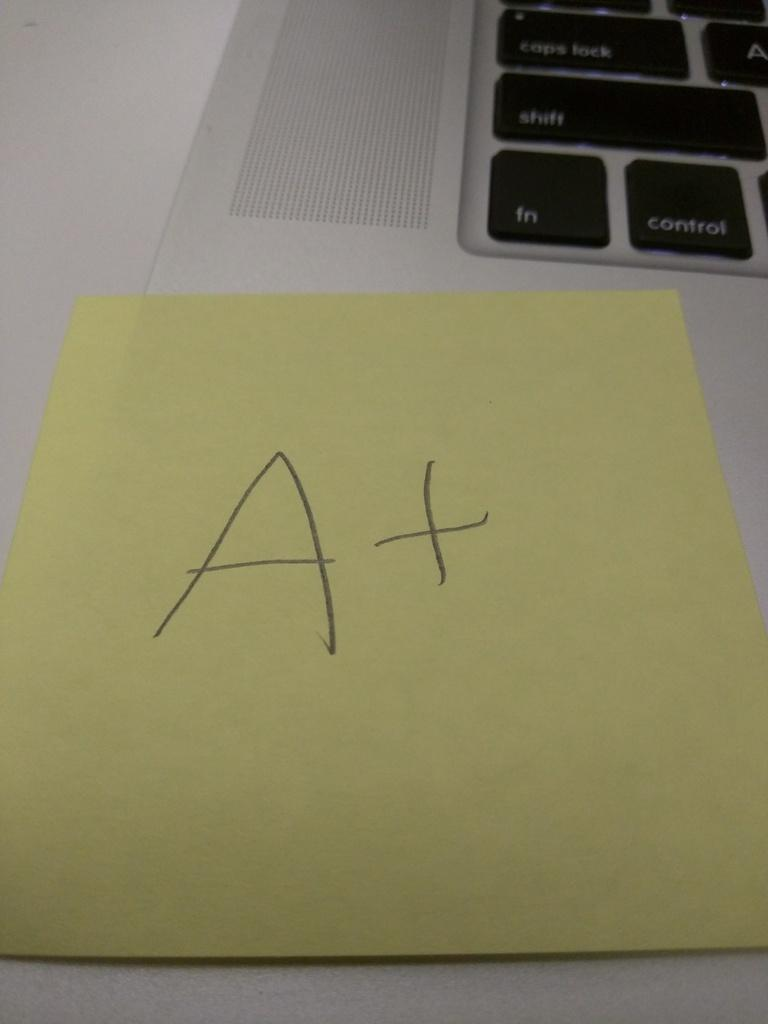<image>
Describe the image concisely. a post it note on top of a laptop keyboard that says 'A+' on it 